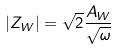<formula> <loc_0><loc_0><loc_500><loc_500>| Z _ { W } | = \sqrt { 2 } \frac { A _ { W } } { \sqrt { \omega } }</formula> 